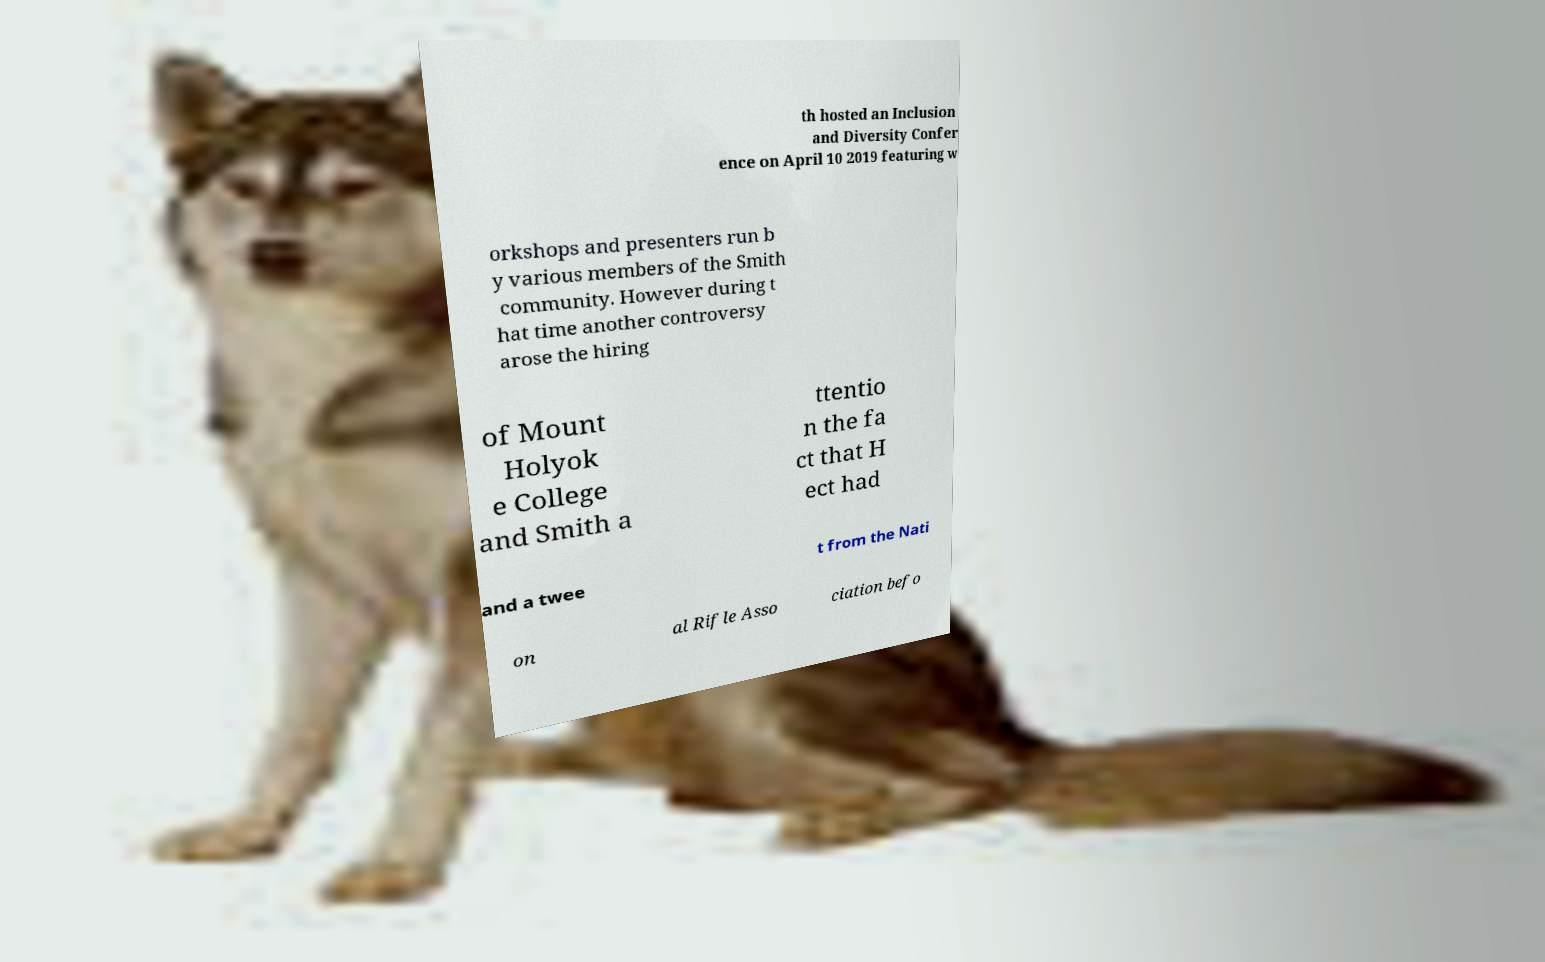Please read and relay the text visible in this image. What does it say? th hosted an Inclusion and Diversity Confer ence on April 10 2019 featuring w orkshops and presenters run b y various members of the Smith community. However during t hat time another controversy arose the hiring of Mount Holyok e College and Smith a ttentio n the fa ct that H ect had and a twee t from the Nati on al Rifle Asso ciation befo 